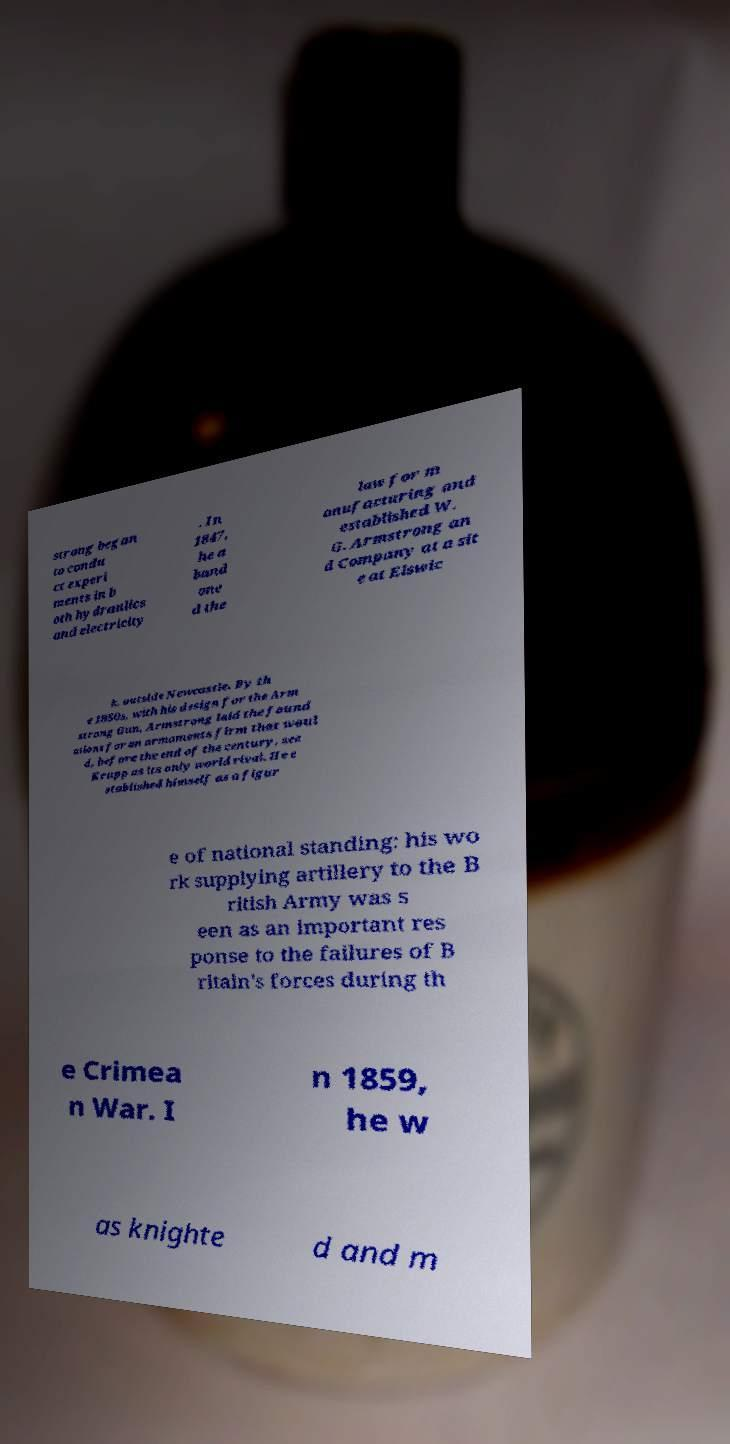Could you extract and type out the text from this image? strong began to condu ct experi ments in b oth hydraulics and electricity . In 1847, he a band one d the law for m anufacturing and established W. G. Armstrong an d Company at a sit e at Elswic k, outside Newcastle. By th e 1850s, with his design for the Arm strong Gun, Armstrong laid the found ations for an armaments firm that woul d, before the end of the century, see Krupp as its only world rival. He e stablished himself as a figur e of national standing: his wo rk supplying artillery to the B ritish Army was s een as an important res ponse to the failures of B ritain's forces during th e Crimea n War. I n 1859, he w as knighte d and m 